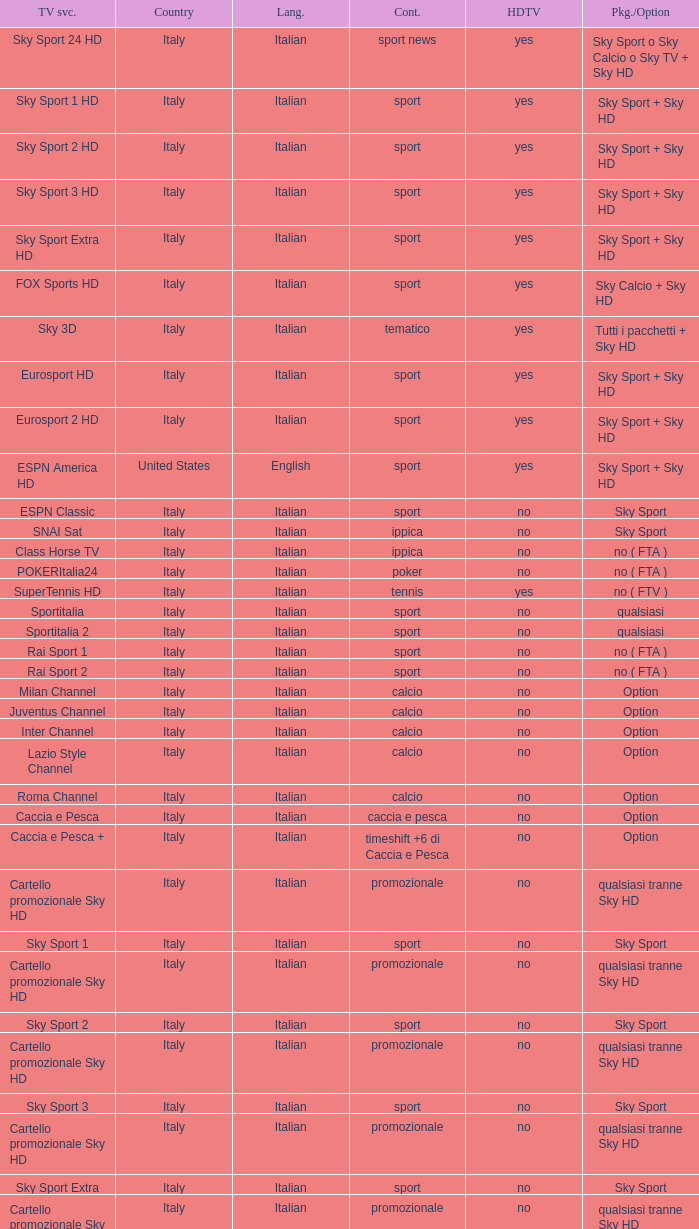What is Language, when Content is Sport, when HDTV is No, and when Television Service is ESPN America? Italian. 